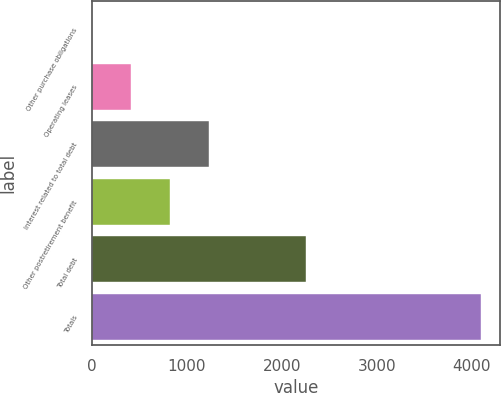<chart> <loc_0><loc_0><loc_500><loc_500><bar_chart><fcel>Other purchase obligations<fcel>Operating leases<fcel>Interest related to total debt<fcel>Other postretirement benefit<fcel>Total debt<fcel>Totals<nl><fcel>7<fcel>415.4<fcel>1232.2<fcel>823.8<fcel>2253<fcel>4091<nl></chart> 